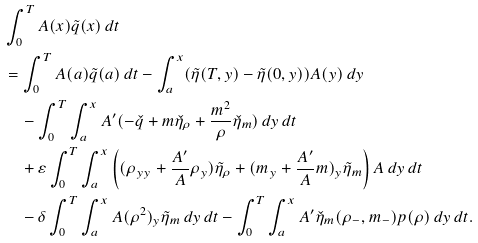<formula> <loc_0><loc_0><loc_500><loc_500>& \int _ { 0 } ^ { T } A ( x ) \tilde { q } ( x ) \, d t \\ & = \int _ { 0 } ^ { T } A ( a ) \tilde { q } ( a ) \, d t - \int _ { a } ^ { x } ( \tilde { \eta } ( T , y ) - \tilde { \eta } ( 0 , y ) ) A ( y ) \, d y \\ & \quad - \int _ { 0 } ^ { T } \int _ { a } ^ { x } A ^ { \prime } ( - \check { q } + m \check { \eta } _ { \rho } + \frac { m ^ { 2 } } { \rho } \check { \eta } _ { m } ) \, d y \, d t \\ & \quad + \varepsilon \int _ { 0 } ^ { T } \int _ { a } ^ { x } \left ( ( \rho _ { y y } + \frac { A ^ { \prime } } { A } \rho _ { y } ) \tilde { \eta } _ { \rho } + ( m _ { y } + \frac { A ^ { \prime } } { A } m ) _ { y } \tilde { \eta } _ { m } \right ) A \, d y \, d t \\ & \quad - \delta \int _ { 0 } ^ { T } \int _ { a } ^ { x } A ( \rho ^ { 2 } ) _ { y } \tilde { \eta } _ { m } \, d y \, d t - \int _ { 0 } ^ { T } \int _ { a } ^ { x } A ^ { \prime } \check { \eta } _ { m } ( \rho _ { - } , m _ { - } ) p ( \rho ) \, d y \, d t .</formula> 